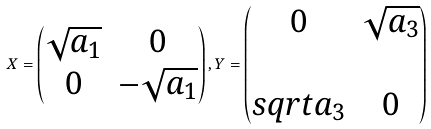Convert formula to latex. <formula><loc_0><loc_0><loc_500><loc_500>X = \begin{pmatrix} \sqrt { a _ { 1 } } & 0 \\ 0 & - \sqrt { a _ { 1 } } \end{pmatrix} , Y = \begin{pmatrix} 0 & \sqrt { a _ { 3 } } \\ \\ s q r t { a _ { 3 } } & 0 \end{pmatrix}</formula> 